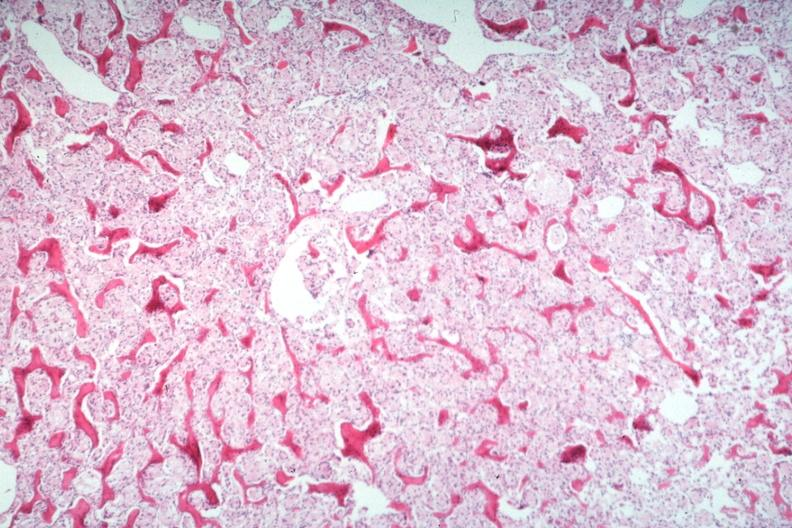does metastatic carcinoma breast show stomach primary?
Answer the question using a single word or phrase. No 